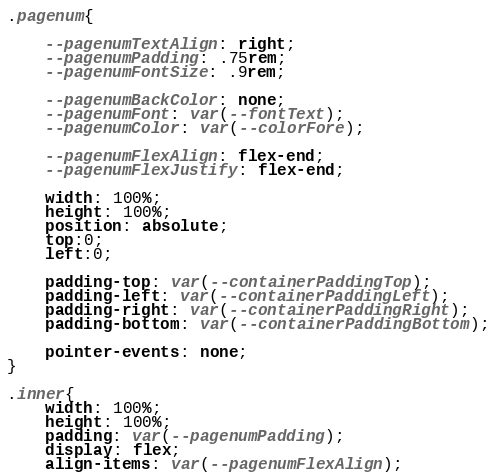<code> <loc_0><loc_0><loc_500><loc_500><_CSS_>
.pagenum{

    --pagenumTextAlign: right;
    --pagenumPadding: .75rem;
    --pagenumFontSize: .9rem;
    
    --pagenumBackColor: none;
    --pagenumFont: var(--fontText);
    --pagenumColor: var(--colorFore);

    --pagenumFlexAlign: flex-end;
    --pagenumFlexJustify: flex-end;

    width: 100%;
    height: 100%;
    position: absolute;
    top:0;
    left:0;

    padding-top: var(--containerPaddingTop);
    padding-left: var(--containerPaddingLeft);
    padding-right: var(--containerPaddingRight);
    padding-bottom: var(--containerPaddingBottom);

    pointer-events: none;
}

.inner{
    width: 100%;
    height: 100%;
    padding: var(--pagenumPadding);
    display: flex;
    align-items: var(--pagenumFlexAlign);</code> 